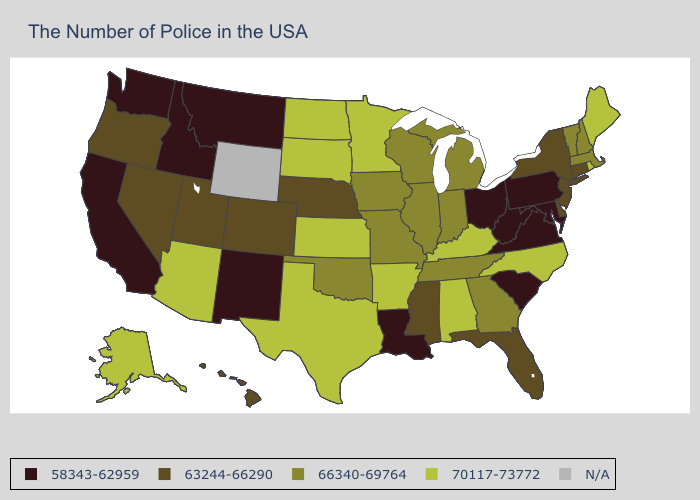What is the highest value in states that border Rhode Island?
Give a very brief answer. 66340-69764. What is the value of Alaska?
Answer briefly. 70117-73772. Among the states that border Rhode Island , which have the highest value?
Answer briefly. Massachusetts. What is the highest value in the Northeast ?
Answer briefly. 70117-73772. What is the lowest value in the USA?
Be succinct. 58343-62959. Does the first symbol in the legend represent the smallest category?
Concise answer only. Yes. Which states have the lowest value in the MidWest?
Write a very short answer. Ohio. Among the states that border Minnesota , which have the lowest value?
Write a very short answer. Wisconsin, Iowa. What is the highest value in the USA?
Be succinct. 70117-73772. Which states hav the highest value in the South?
Short answer required. North Carolina, Kentucky, Alabama, Arkansas, Texas. Which states have the lowest value in the USA?
Short answer required. Maryland, Pennsylvania, Virginia, South Carolina, West Virginia, Ohio, Louisiana, New Mexico, Montana, Idaho, California, Washington. Does Alabama have the lowest value in the South?
Short answer required. No. Name the states that have a value in the range N/A?
Give a very brief answer. Wyoming. 